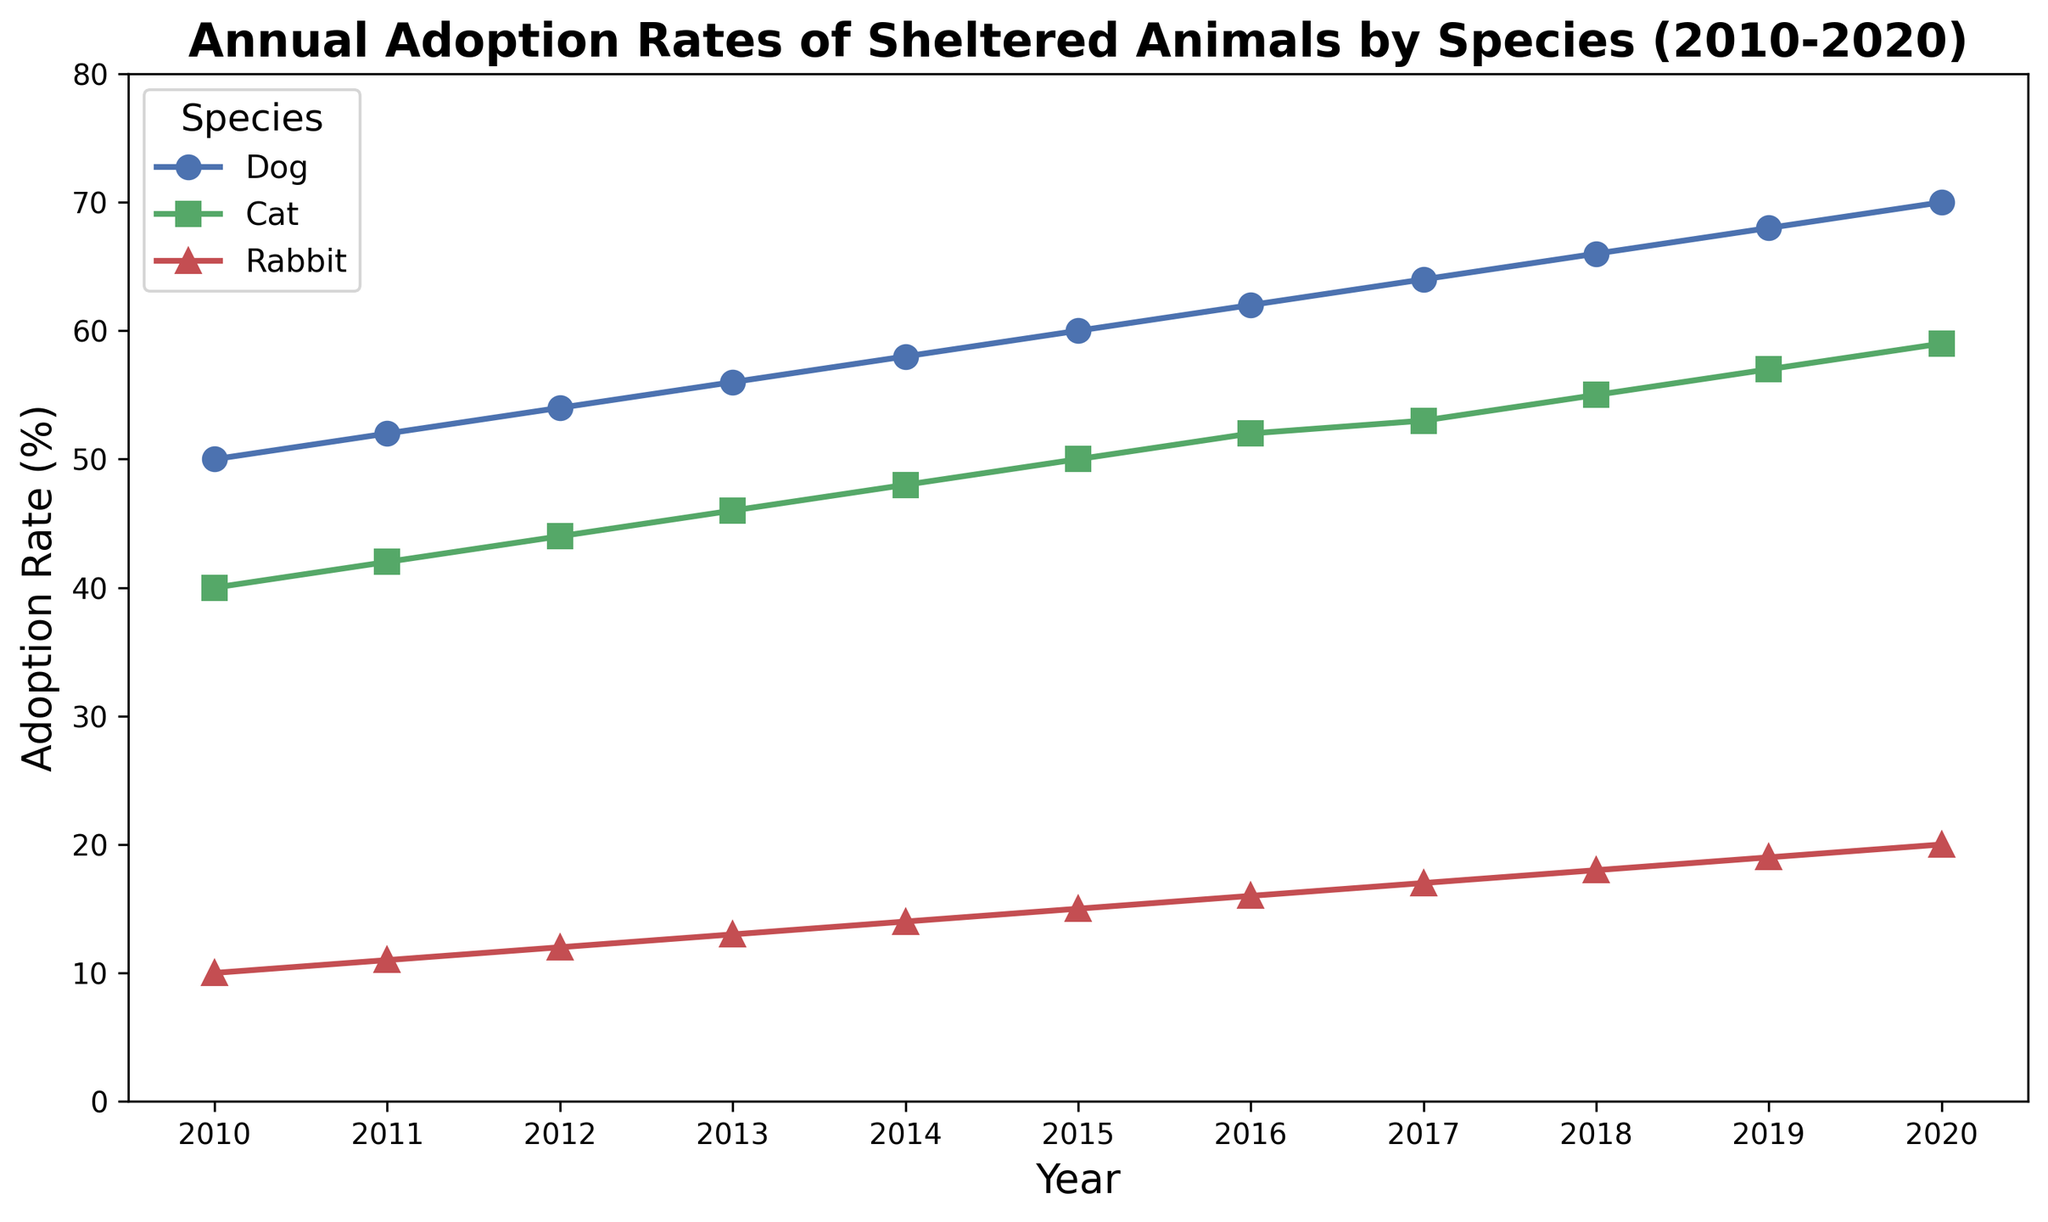What is the adoption rate of dogs in 2015? Find the data point where the year is 2015 and the species is Dog. According to the chart, the adoption rate for dogs in 2015 is marked at 60%.
Answer: 60% Which species had the lowest adoption rate in 2013? Compare the adoption rates for dogs, cats, and rabbits in 2013. The data shows that rabbits had the lowest adoption rate, which is 13%.
Answer: Rabbit Between 2010 and 2020, which species showed the greatest increase in adoption rate? Calculate the difference between the adoption rates in 2010 and 2020 for each species. Dogs increased from 50% to 70% (20% increase), cats from 40% to 59% (19% increase), and rabbits from 10% to 20% (10% increase). Dogs had the greatest increase.
Answer: Dog What was the average adoption rate for cats between 2010 and 2015? Add the adoption rates for cats from 2010 to 2015 and divide by the number of years: (40% + 42% + 44% + 46% + 48% + 50%) / 6 = 45%.
Answer: 45% In which year did all three species have a combined adoption rate of over 100%? Add the adoption rates for all species for each year and check when they exceed 100%. In 2020: 70% (Dog) + 59% (Cat) + 20% (Rabbit) = 149%.
Answer: 2020 By how much did the adoption rate of rabbits increase from 2011 to 2017? Find the adoption rates for rabbits in 2011 and 2017, then calculate the difference: 17% - 11% = 6%.
Answer: 6% What is the trend in the adoption rates for cats from 2010 to 2020? Observe the line representing cats' adoption rates. It shows a consistent increase from 40% in 2010 to 59% in 2020.
Answer: Increasing In which year did dogs have an adoption rate of 64%? Look at the plot line for dogs and identify the year where the adoption rate is 64%. It is in 2017.
Answer: 2017 Which species had the highest adoption rate in 2010, and what was it? Compare the adoption rates in 2010 for all species. Dogs had the highest rate at 50%.
Answer: Dog, 50% What was the rate of increase in cat adoption from 2018 to 2020? Find the adoption rates for cats in 2018 and 2020 and calculate the difference: 59% - 55% = 4%.
Answer: 4% 